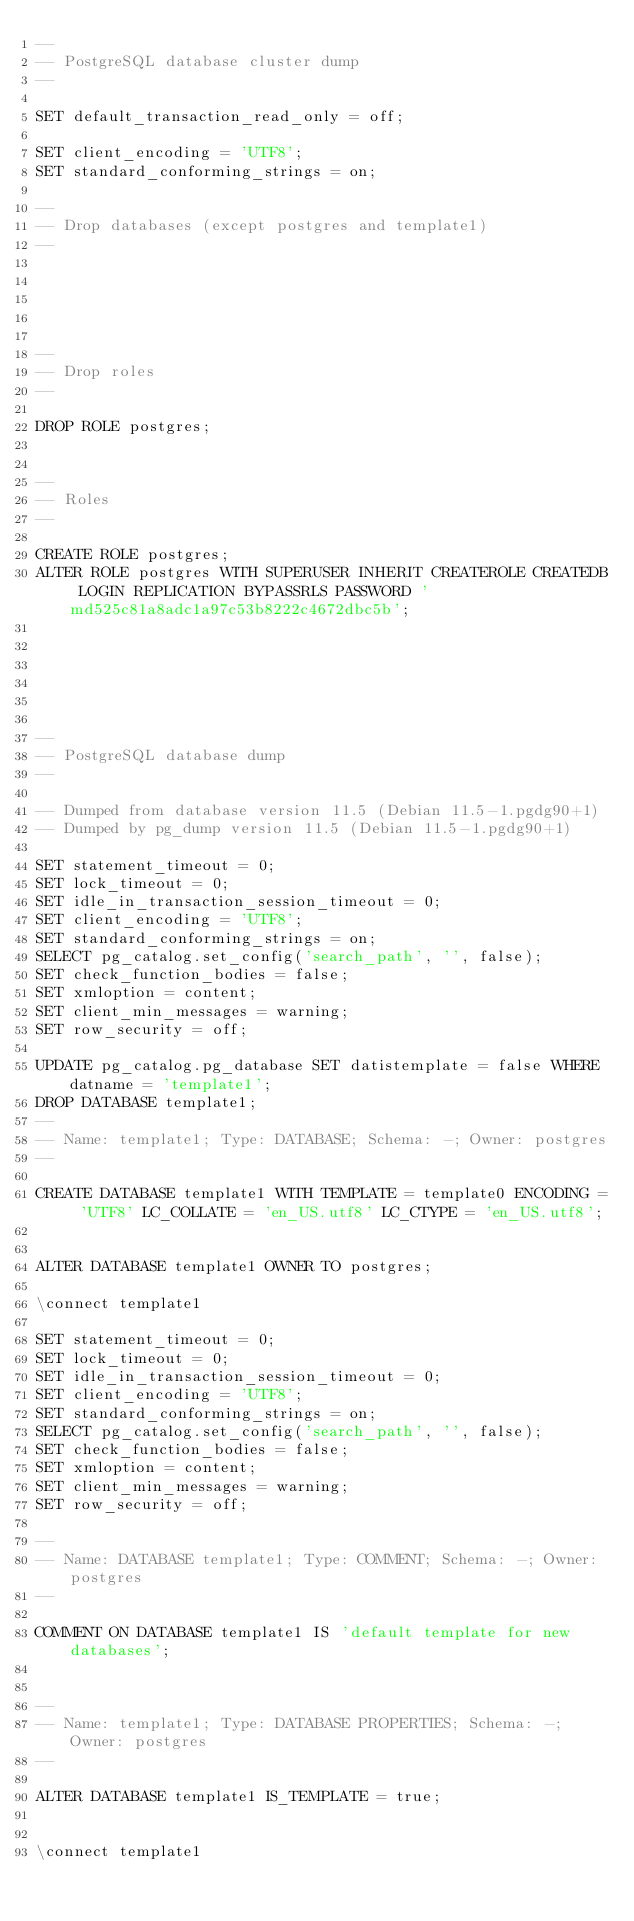Convert code to text. <code><loc_0><loc_0><loc_500><loc_500><_SQL_>--
-- PostgreSQL database cluster dump
--

SET default_transaction_read_only = off;

SET client_encoding = 'UTF8';
SET standard_conforming_strings = on;

--
-- Drop databases (except postgres and template1)
--





--
-- Drop roles
--

DROP ROLE postgres;


--
-- Roles
--

CREATE ROLE postgres;
ALTER ROLE postgres WITH SUPERUSER INHERIT CREATEROLE CREATEDB LOGIN REPLICATION BYPASSRLS PASSWORD 'md525c81a8adc1a97c53b8222c4672dbc5b';






--
-- PostgreSQL database dump
--

-- Dumped from database version 11.5 (Debian 11.5-1.pgdg90+1)
-- Dumped by pg_dump version 11.5 (Debian 11.5-1.pgdg90+1)

SET statement_timeout = 0;
SET lock_timeout = 0;
SET idle_in_transaction_session_timeout = 0;
SET client_encoding = 'UTF8';
SET standard_conforming_strings = on;
SELECT pg_catalog.set_config('search_path', '', false);
SET check_function_bodies = false;
SET xmloption = content;
SET client_min_messages = warning;
SET row_security = off;

UPDATE pg_catalog.pg_database SET datistemplate = false WHERE datname = 'template1';
DROP DATABASE template1;
--
-- Name: template1; Type: DATABASE; Schema: -; Owner: postgres
--

CREATE DATABASE template1 WITH TEMPLATE = template0 ENCODING = 'UTF8' LC_COLLATE = 'en_US.utf8' LC_CTYPE = 'en_US.utf8';


ALTER DATABASE template1 OWNER TO postgres;

\connect template1

SET statement_timeout = 0;
SET lock_timeout = 0;
SET idle_in_transaction_session_timeout = 0;
SET client_encoding = 'UTF8';
SET standard_conforming_strings = on;
SELECT pg_catalog.set_config('search_path', '', false);
SET check_function_bodies = false;
SET xmloption = content;
SET client_min_messages = warning;
SET row_security = off;

--
-- Name: DATABASE template1; Type: COMMENT; Schema: -; Owner: postgres
--

COMMENT ON DATABASE template1 IS 'default template for new databases';


--
-- Name: template1; Type: DATABASE PROPERTIES; Schema: -; Owner: postgres
--

ALTER DATABASE template1 IS_TEMPLATE = true;


\connect template1
</code> 